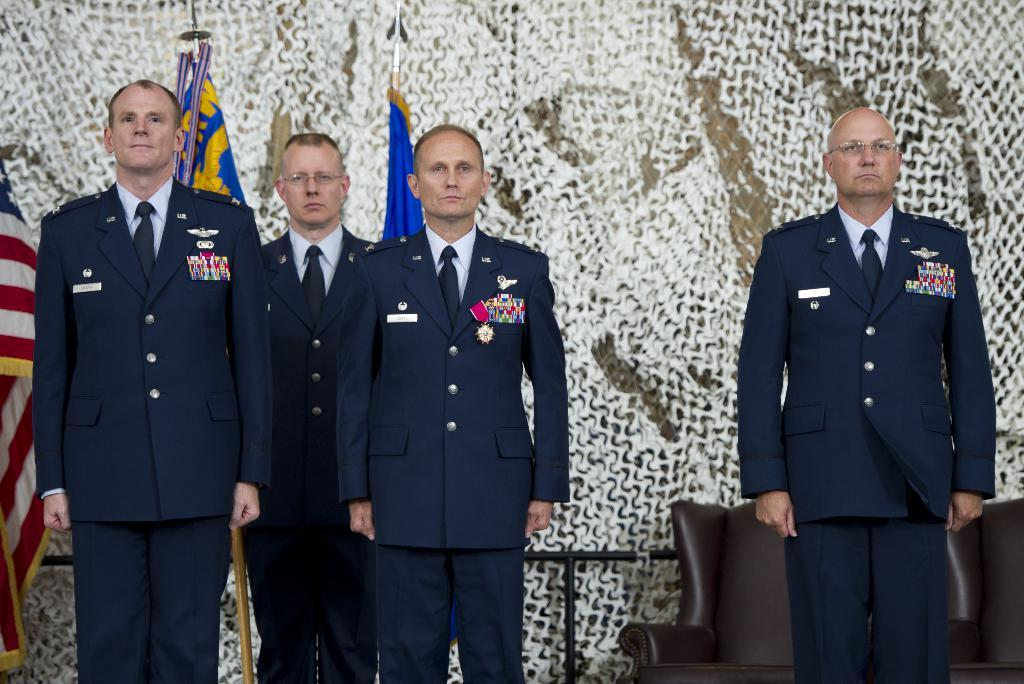What are the people in the image wearing? The people in the image are wearing costumes. Can you describe any furniture in the image? There is at least one chair in the image. What objects in the image are long and thin? There are rods in the image. What type of decorations are present in the image? There are flags in the image. What news headline is displayed on the truck in the image? There is no truck present in the image, so there is no news headline to be displayed. 